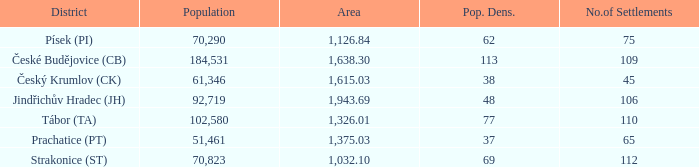How many settlements are in český krumlov (ck) with a population density higher than 38? None. 